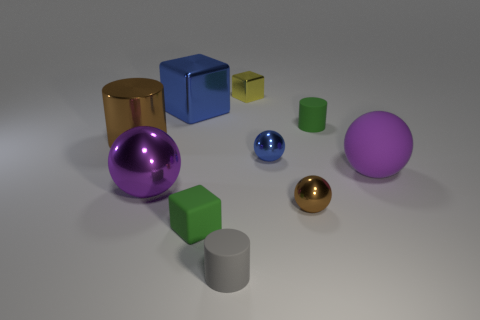There is a thing that is both behind the big brown metallic cylinder and in front of the large metal cube; what is its material?
Ensure brevity in your answer.  Rubber. Do the metal block that is right of the blue block and the large brown cylinder have the same size?
Keep it short and to the point. No. There is a metallic cylinder; is it the same size as the matte cylinder in front of the tiny brown metal thing?
Offer a terse response. No. What material is the large object in front of the large object to the right of the tiny green thing in front of the matte ball?
Keep it short and to the point. Metal. How many things are either brown shiny spheres or green matte spheres?
Provide a short and direct response. 1. There is a tiny rubber cylinder behind the rubber block; does it have the same color as the block in front of the brown cylinder?
Give a very brief answer. Yes. The yellow object that is the same size as the rubber cube is what shape?
Give a very brief answer. Cube. What number of things are blue shiny things that are behind the brown cylinder or big objects in front of the large matte object?
Give a very brief answer. 2. Is the number of tiny green rubber objects less than the number of small gray matte cylinders?
Your answer should be very brief. No. What is the material of the gray object that is the same size as the yellow shiny object?
Your response must be concise. Rubber. 